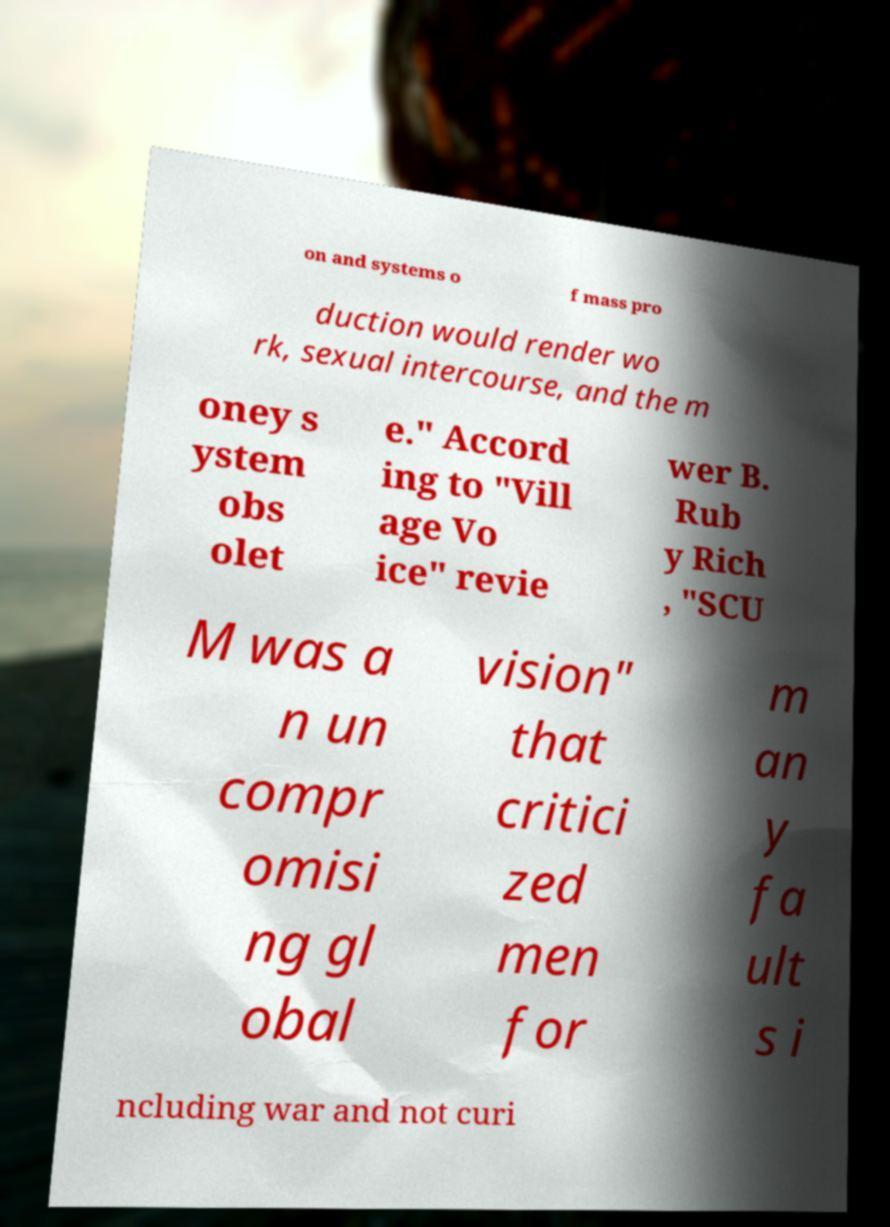There's text embedded in this image that I need extracted. Can you transcribe it verbatim? on and systems o f mass pro duction would render wo rk, sexual intercourse, and the m oney s ystem obs olet e." Accord ing to "Vill age Vo ice" revie wer B. Rub y Rich , "SCU M was a n un compr omisi ng gl obal vision" that critici zed men for m an y fa ult s i ncluding war and not curi 